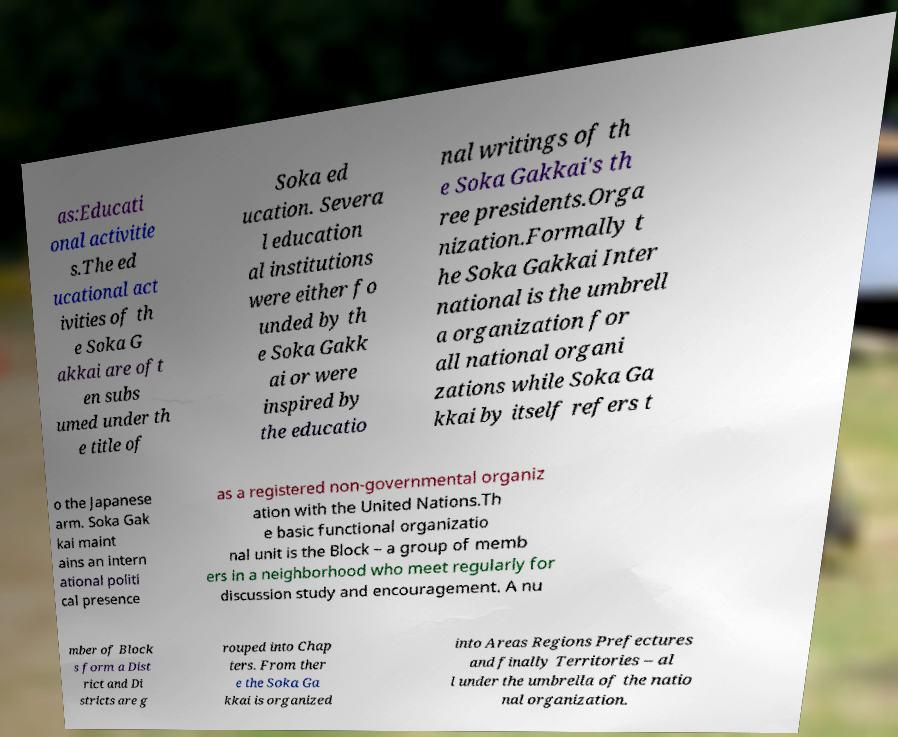I need the written content from this picture converted into text. Can you do that? as:Educati onal activitie s.The ed ucational act ivities of th e Soka G akkai are oft en subs umed under th e title of Soka ed ucation. Severa l education al institutions were either fo unded by th e Soka Gakk ai or were inspired by the educatio nal writings of th e Soka Gakkai's th ree presidents.Orga nization.Formally t he Soka Gakkai Inter national is the umbrell a organization for all national organi zations while Soka Ga kkai by itself refers t o the Japanese arm. Soka Gak kai maint ains an intern ational politi cal presence as a registered non-governmental organiz ation with the United Nations.Th e basic functional organizatio nal unit is the Block – a group of memb ers in a neighborhood who meet regularly for discussion study and encouragement. A nu mber of Block s form a Dist rict and Di stricts are g rouped into Chap ters. From ther e the Soka Ga kkai is organized into Areas Regions Prefectures and finally Territories – al l under the umbrella of the natio nal organization. 